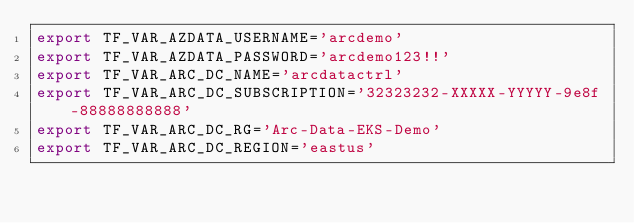<code> <loc_0><loc_0><loc_500><loc_500><_Bash_>export TF_VAR_AZDATA_USERNAME='arcdemo'
export TF_VAR_AZDATA_PASSWORD='arcdemo123!!'
export TF_VAR_ARC_DC_NAME='arcdatactrl'
export TF_VAR_ARC_DC_SUBSCRIPTION='32323232-XXXXX-YYYYY-9e8f-88888888888'
export TF_VAR_ARC_DC_RG='Arc-Data-EKS-Demo'
export TF_VAR_ARC_DC_REGION='eastus'</code> 